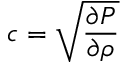Convert formula to latex. <formula><loc_0><loc_0><loc_500><loc_500>c = \sqrt { \frac { \partial P } { \partial \rho } }</formula> 